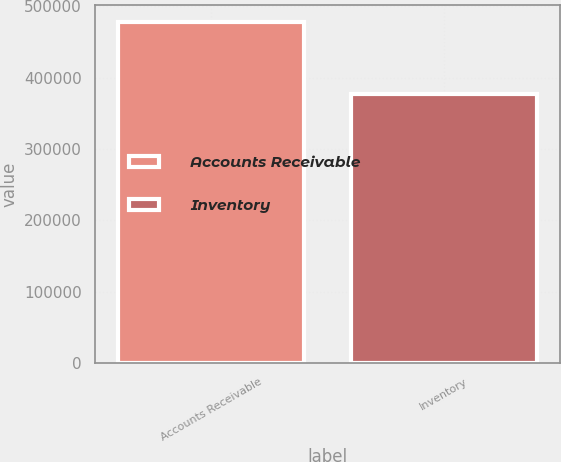Convert chart. <chart><loc_0><loc_0><loc_500><loc_500><bar_chart><fcel>Accounts Receivable<fcel>Inventory<nl><fcel>477609<fcel>376555<nl></chart> 